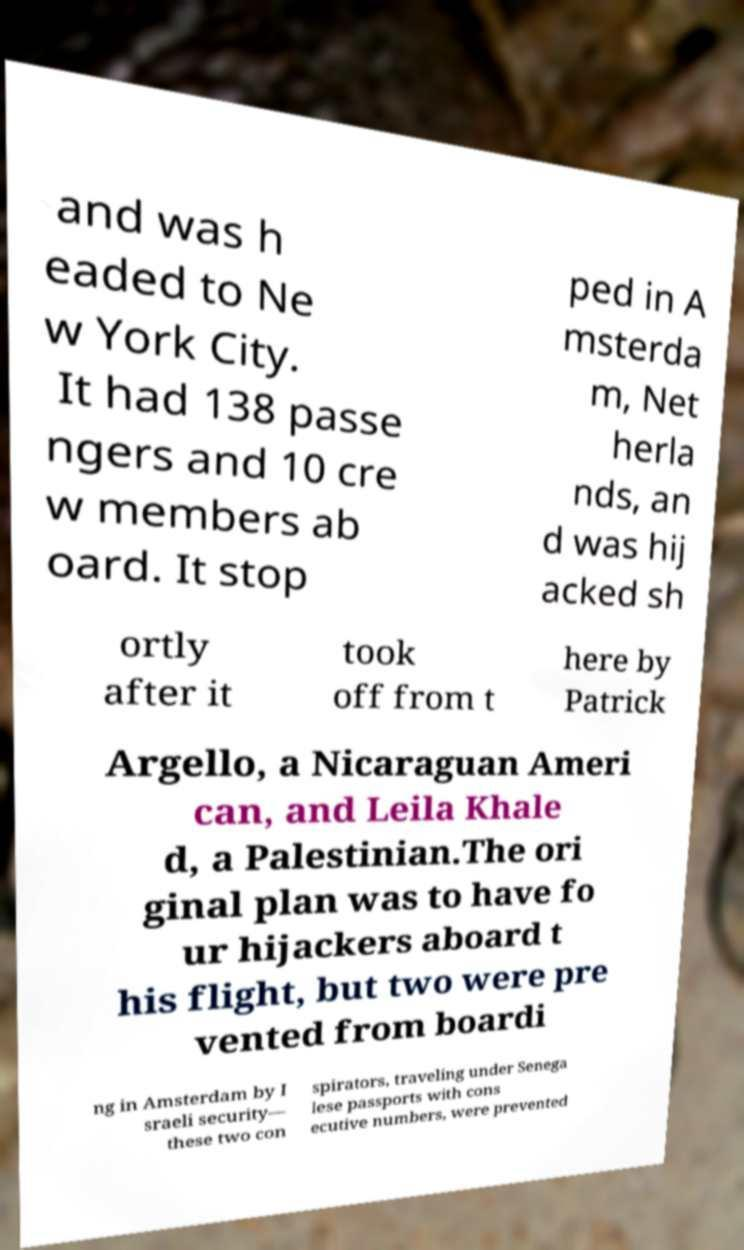Can you read and provide the text displayed in the image?This photo seems to have some interesting text. Can you extract and type it out for me? and was h eaded to Ne w York City. It had 138 passe ngers and 10 cre w members ab oard. It stop ped in A msterda m, Net herla nds, an d was hij acked sh ortly after it took off from t here by Patrick Argello, a Nicaraguan Ameri can, and Leila Khale d, a Palestinian.The ori ginal plan was to have fo ur hijackers aboard t his flight, but two were pre vented from boardi ng in Amsterdam by I sraeli security— these two con spirators, traveling under Senega lese passports with cons ecutive numbers, were prevented 